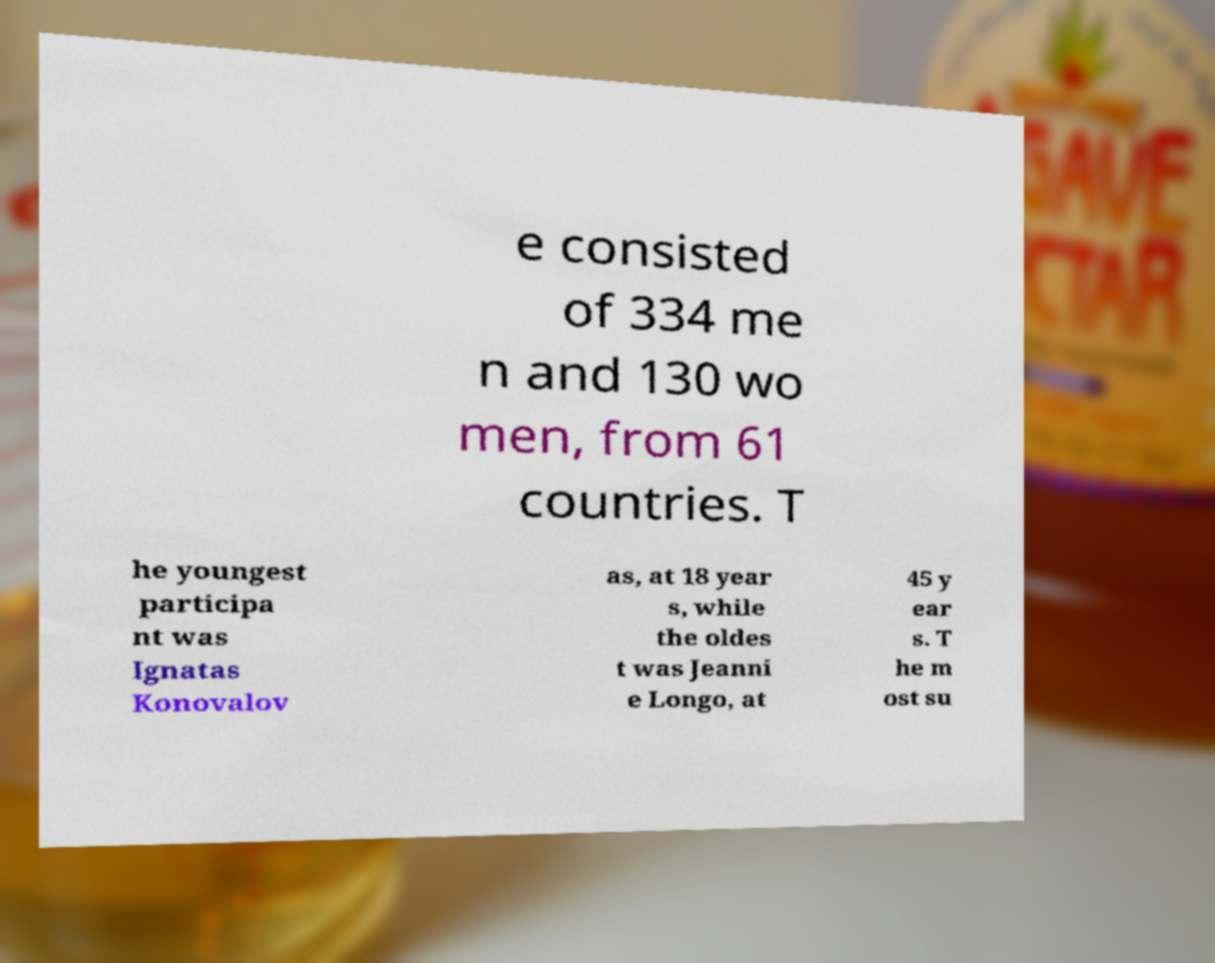Please identify and transcribe the text found in this image. e consisted of 334 me n and 130 wo men, from 61 countries. T he youngest participa nt was Ignatas Konovalov as, at 18 year s, while the oldes t was Jeanni e Longo, at 45 y ear s. T he m ost su 